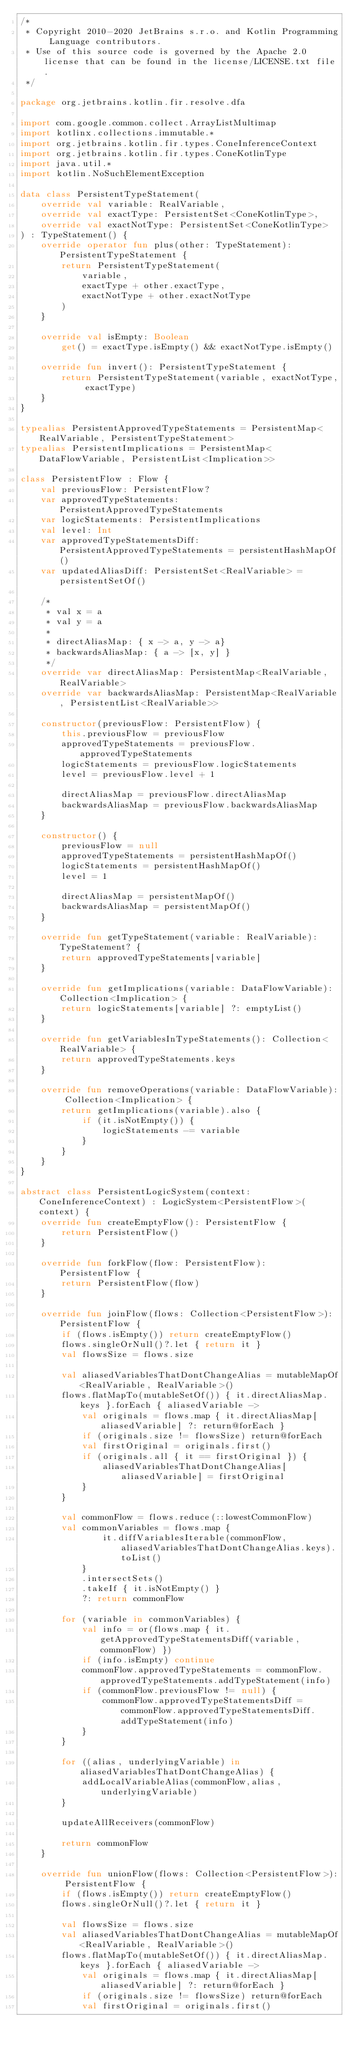Convert code to text. <code><loc_0><loc_0><loc_500><loc_500><_Kotlin_>/*
 * Copyright 2010-2020 JetBrains s.r.o. and Kotlin Programming Language contributors.
 * Use of this source code is governed by the Apache 2.0 license that can be found in the license/LICENSE.txt file.
 */

package org.jetbrains.kotlin.fir.resolve.dfa

import com.google.common.collect.ArrayListMultimap
import kotlinx.collections.immutable.*
import org.jetbrains.kotlin.fir.types.ConeInferenceContext
import org.jetbrains.kotlin.fir.types.ConeKotlinType
import java.util.*
import kotlin.NoSuchElementException

data class PersistentTypeStatement(
    override val variable: RealVariable,
    override val exactType: PersistentSet<ConeKotlinType>,
    override val exactNotType: PersistentSet<ConeKotlinType>
) : TypeStatement() {
    override operator fun plus(other: TypeStatement): PersistentTypeStatement {
        return PersistentTypeStatement(
            variable,
            exactType + other.exactType,
            exactNotType + other.exactNotType
        )
    }

    override val isEmpty: Boolean
        get() = exactType.isEmpty() && exactNotType.isEmpty()

    override fun invert(): PersistentTypeStatement {
        return PersistentTypeStatement(variable, exactNotType, exactType)
    }
}

typealias PersistentApprovedTypeStatements = PersistentMap<RealVariable, PersistentTypeStatement>
typealias PersistentImplications = PersistentMap<DataFlowVariable, PersistentList<Implication>>

class PersistentFlow : Flow {
    val previousFlow: PersistentFlow?
    var approvedTypeStatements: PersistentApprovedTypeStatements
    var logicStatements: PersistentImplications
    val level: Int
    var approvedTypeStatementsDiff: PersistentApprovedTypeStatements = persistentHashMapOf()
    var updatedAliasDiff: PersistentSet<RealVariable> = persistentSetOf()

    /*
     * val x = a
     * val y = a
     *
     * directAliasMap: { x -> a, y -> a}
     * backwardsAliasMap: { a -> [x, y] }
     */
    override var directAliasMap: PersistentMap<RealVariable, RealVariable>
    override var backwardsAliasMap: PersistentMap<RealVariable, PersistentList<RealVariable>>

    constructor(previousFlow: PersistentFlow) {
        this.previousFlow = previousFlow
        approvedTypeStatements = previousFlow.approvedTypeStatements
        logicStatements = previousFlow.logicStatements
        level = previousFlow.level + 1

        directAliasMap = previousFlow.directAliasMap
        backwardsAliasMap = previousFlow.backwardsAliasMap
    }

    constructor() {
        previousFlow = null
        approvedTypeStatements = persistentHashMapOf()
        logicStatements = persistentHashMapOf()
        level = 1

        directAliasMap = persistentMapOf()
        backwardsAliasMap = persistentMapOf()
    }

    override fun getTypeStatement(variable: RealVariable): TypeStatement? {
        return approvedTypeStatements[variable]
    }

    override fun getImplications(variable: DataFlowVariable): Collection<Implication> {
        return logicStatements[variable] ?: emptyList()
    }

    override fun getVariablesInTypeStatements(): Collection<RealVariable> {
        return approvedTypeStatements.keys
    }

    override fun removeOperations(variable: DataFlowVariable): Collection<Implication> {
        return getImplications(variable).also {
            if (it.isNotEmpty()) {
                logicStatements -= variable
            }
        }
    }
}

abstract class PersistentLogicSystem(context: ConeInferenceContext) : LogicSystem<PersistentFlow>(context) {
    override fun createEmptyFlow(): PersistentFlow {
        return PersistentFlow()
    }

    override fun forkFlow(flow: PersistentFlow): PersistentFlow {
        return PersistentFlow(flow)
    }

    override fun joinFlow(flows: Collection<PersistentFlow>): PersistentFlow {
        if (flows.isEmpty()) return createEmptyFlow()
        flows.singleOrNull()?.let { return it }
        val flowsSize = flows.size

        val aliasedVariablesThatDontChangeAlias = mutableMapOf<RealVariable, RealVariable>()
        flows.flatMapTo(mutableSetOf()) { it.directAliasMap.keys }.forEach { aliasedVariable ->
            val originals = flows.map { it.directAliasMap[aliasedVariable] ?: return@forEach }
            if (originals.size != flowsSize) return@forEach
            val firstOriginal = originals.first()
            if (originals.all { it == firstOriginal }) {
                aliasedVariablesThatDontChangeAlias[aliasedVariable] = firstOriginal
            }
        }

        val commonFlow = flows.reduce(::lowestCommonFlow)
        val commonVariables = flows.map {
                it.diffVariablesIterable(commonFlow, aliasedVariablesThatDontChangeAlias.keys).toList()
            }
            .intersectSets()
            .takeIf { it.isNotEmpty() }
            ?: return commonFlow

        for (variable in commonVariables) {
            val info = or(flows.map { it.getApprovedTypeStatementsDiff(variable, commonFlow) })
            if (info.isEmpty) continue
            commonFlow.approvedTypeStatements = commonFlow.approvedTypeStatements.addTypeStatement(info)
            if (commonFlow.previousFlow != null) {
                commonFlow.approvedTypeStatementsDiff = commonFlow.approvedTypeStatementsDiff.addTypeStatement(info)
            }
        }

        for ((alias, underlyingVariable) in aliasedVariablesThatDontChangeAlias) {
            addLocalVariableAlias(commonFlow,alias, underlyingVariable)
        }

        updateAllReceivers(commonFlow)

        return commonFlow
    }

    override fun unionFlow(flows: Collection<PersistentFlow>): PersistentFlow {
        if (flows.isEmpty()) return createEmptyFlow()
        flows.singleOrNull()?.let { return it }

        val flowsSize = flows.size
        val aliasedVariablesThatDontChangeAlias = mutableMapOf<RealVariable, RealVariable>()
        flows.flatMapTo(mutableSetOf()) { it.directAliasMap.keys }.forEach { aliasedVariable ->
            val originals = flows.map { it.directAliasMap[aliasedVariable] ?: return@forEach }
            if (originals.size != flowsSize) return@forEach
            val firstOriginal = originals.first()</code> 